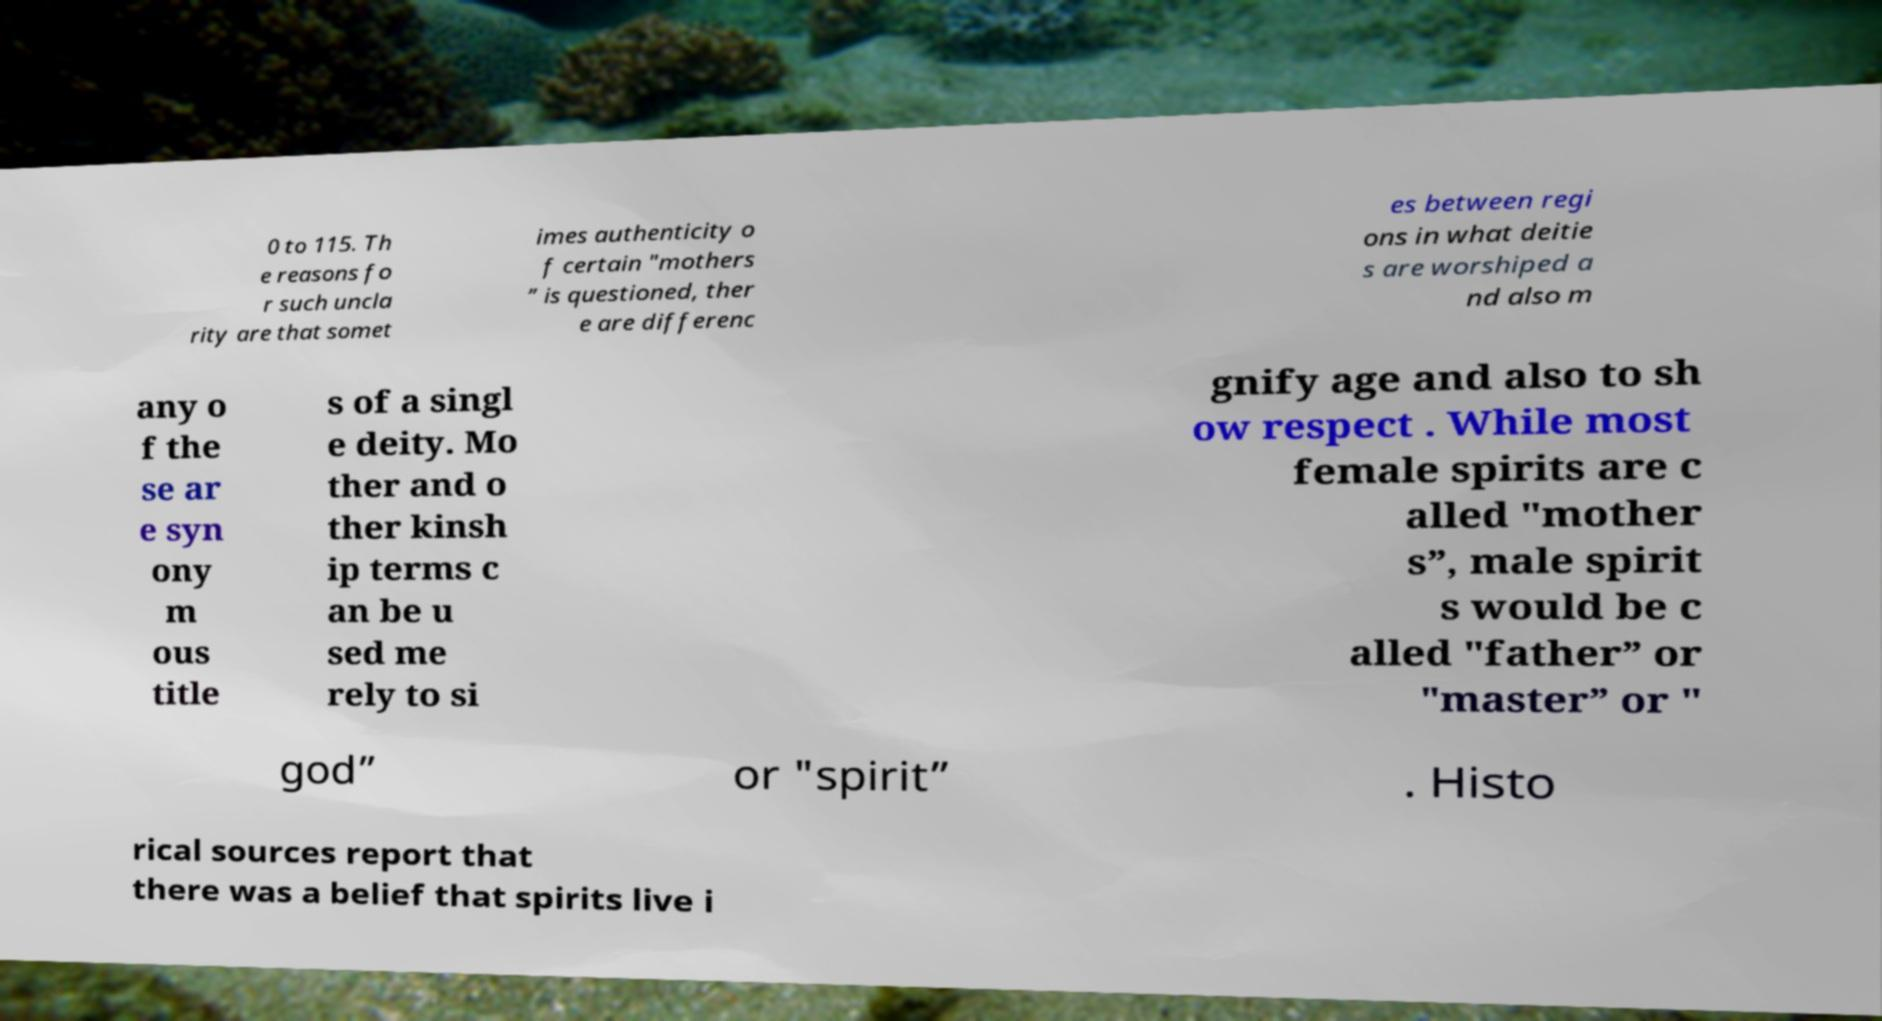For documentation purposes, I need the text within this image transcribed. Could you provide that? 0 to 115. Th e reasons fo r such uncla rity are that somet imes authenticity o f certain "mothers ” is questioned, ther e are differenc es between regi ons in what deitie s are worshiped a nd also m any o f the se ar e syn ony m ous title s of a singl e deity. Mo ther and o ther kinsh ip terms c an be u sed me rely to si gnify age and also to sh ow respect . While most female spirits are c alled "mother s”, male spirit s would be c alled "father” or "master” or " god” or "spirit” . Histo rical sources report that there was a belief that spirits live i 